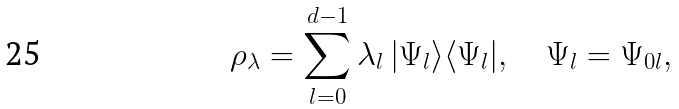Convert formula to latex. <formula><loc_0><loc_0><loc_500><loc_500>\rho _ { \lambda } = \sum _ { l = 0 } ^ { d - 1 } \lambda _ { l } \, | \Psi _ { l } \rangle \langle \Psi _ { l } | , \quad \Psi _ { l } = \Psi _ { 0 l } ,</formula> 